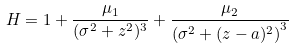Convert formula to latex. <formula><loc_0><loc_0><loc_500><loc_500>H = 1 + \frac { \mu _ { 1 } } { ( \sigma ^ { 2 } + z ^ { 2 } ) ^ { 3 } } + \frac { \mu _ { 2 } } { \left ( \sigma ^ { 2 } + ( z - a ) ^ { 2 } \right ) ^ { 3 } }</formula> 